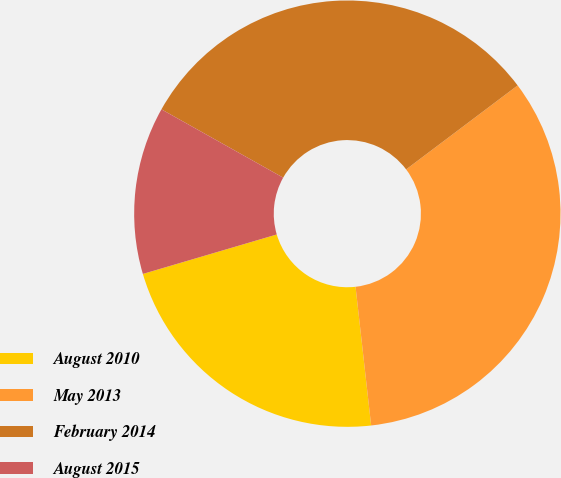<chart> <loc_0><loc_0><loc_500><loc_500><pie_chart><fcel>August 2010<fcel>May 2013<fcel>February 2014<fcel>August 2015<nl><fcel>22.22%<fcel>33.49%<fcel>31.59%<fcel>12.7%<nl></chart> 